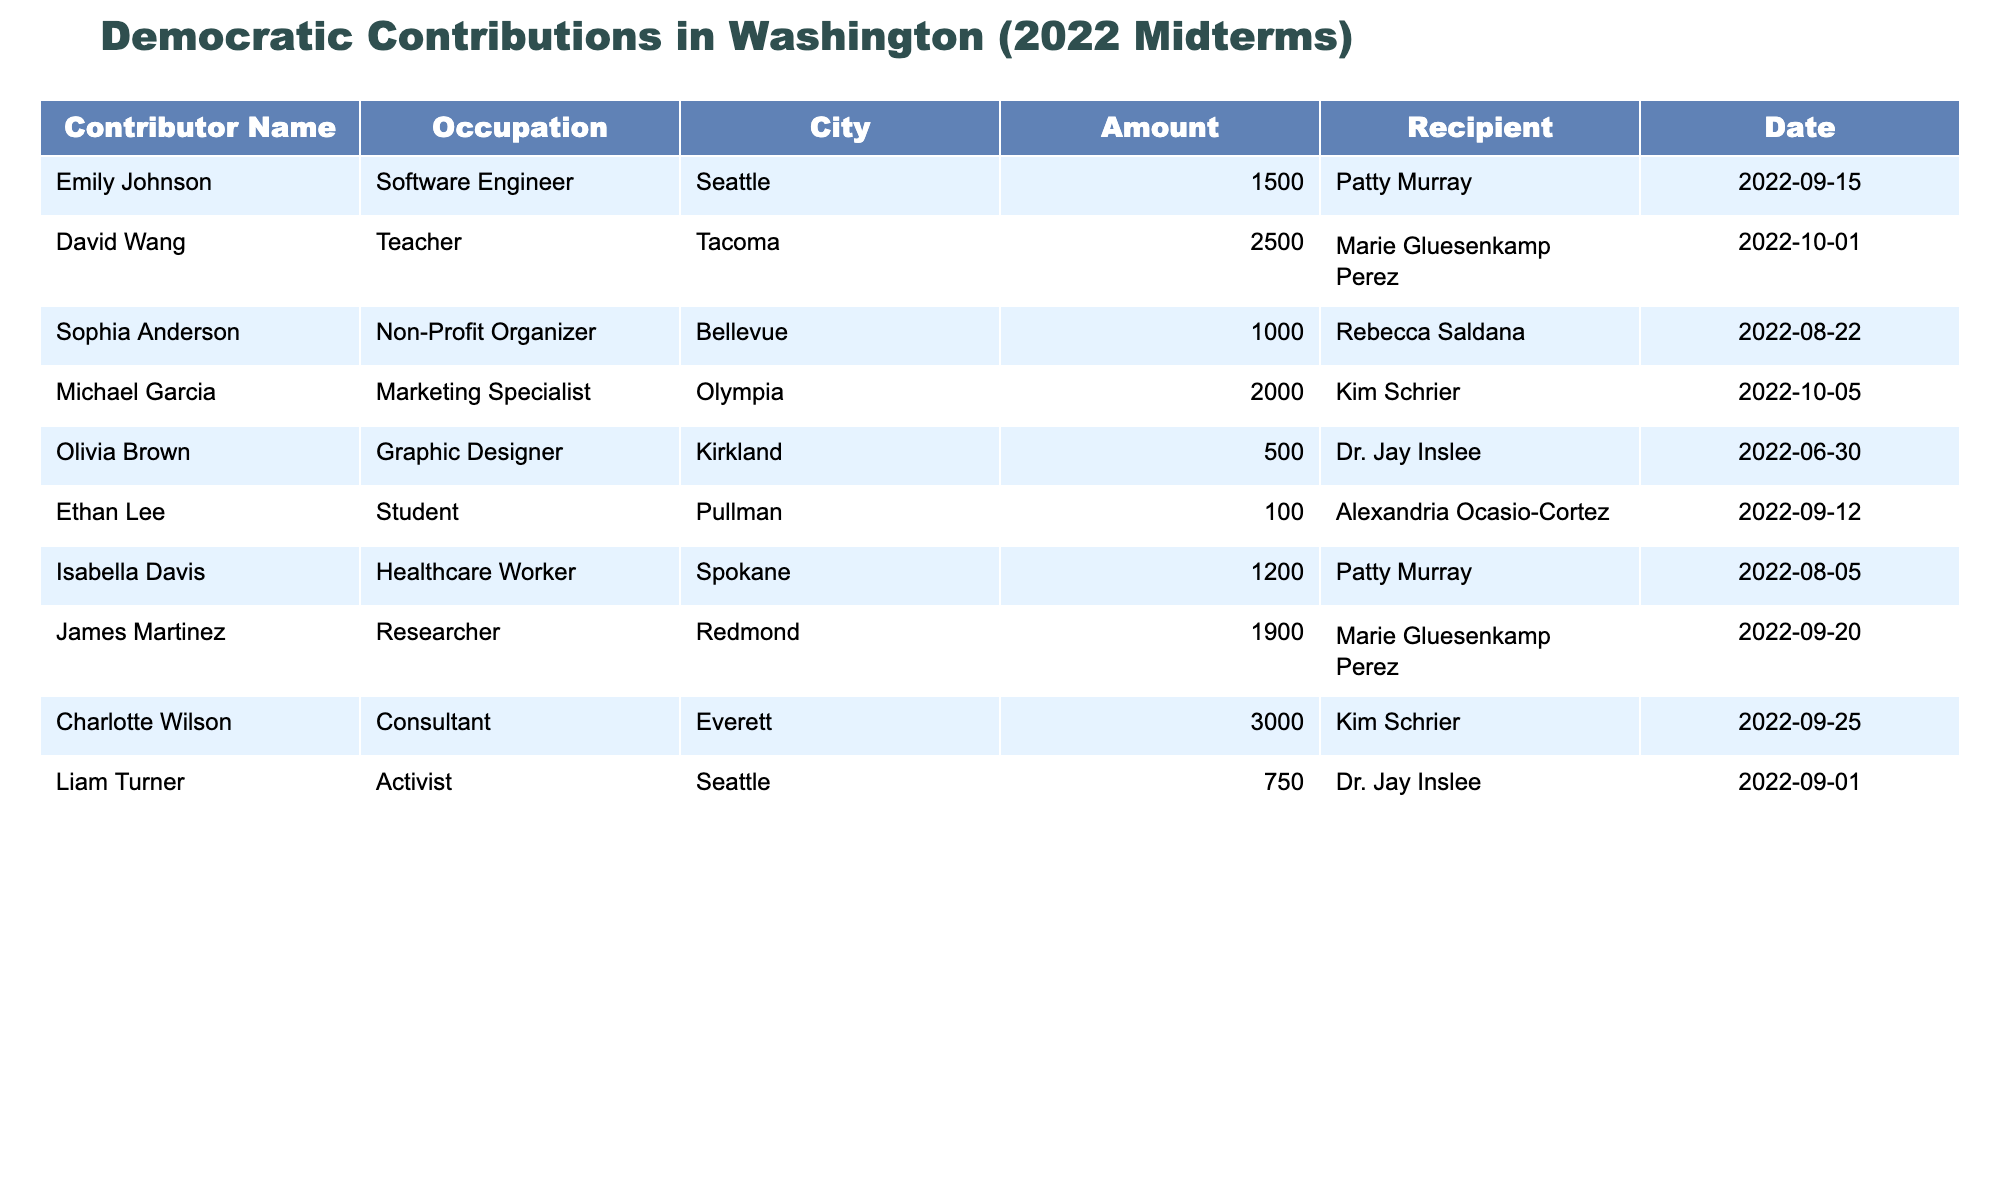What is the largest contribution made by a single individual in the table? The largest contribution in the table is $3000, made by Charlotte Wilson. This can be easily identified by looking through the "Amount" column to find the highest value.
Answer: $3000 Which recipient received the most total money from Washington residents based on the table? To find this, we review the "Recipient" column and sum the amounts associated with each one. Kim Schrier received $500 + $2000 + $3000 = $4500, making her the one with the most contributions.
Answer: Kim Schrier How many contributions were made by people living in Seattle? The table lists contributions from Emily Johnson and Liam Turner from Seattle, totaling two contributions. Each contributor can be directly counted by checking the "City" column for the entries that show Seattle.
Answer: 2 Is there any contributor who is a student? In the "Occupation" column, Ethan Lee is listed as a student, confirming that yes, there is a contributor who is a student.
Answer: Yes What is the total amount contributed by all contributors from Tacoma? In the table, David Wang from Tacoma contributed $2500. Since he's the only contributor from Tacoma in the table, his contribution is the total amount.
Answer: $2500 Which contributor has the highest contribution in the table, and which candidate did they support? Reviewing the "Amount" column, Charlotte Wilson gave $3000 to Kim Schrier. By finding the maximum value, we can attribute the recipient correctly.
Answer: Charlotte Wilson supported Kim Schrier Calculate the average contribution amount from all contributors listed. The total contributions sum up to $1500 + $2500 + $1000 + $2000 + $500 + $100 + $1200 + $1900 + $3000 + $750 = $13800. Since there are 10 contributors, the average is $13800 / 10 = $1380.
Answer: $1380 Are there more contributions made by healthcare workers or software engineers? By checking the "Occupation" column, there is one healthcare worker (Isabella Davis) who contributed $1200 and one software engineer (Emily Johnson) who contributed $1500. Since $1500 > $1200, it shows that more money came from software engineers.
Answer: Software engineers Which city has the most contributors in the table? Analyzing the "City" column shows that Seattle and Tacoma have two contributors each, while other cities only have one. Since they are tied, we conclude that these are the cities with the most contributors.
Answer: Seattle and Tacoma What is the sum of contributions made to Dr. Jay Inslee? Contributions listed for Dr. Jay Inslee are $500 from Olivia Brown and $750 from Liam Turner, totaling $500 + $750 = $1250.
Answer: $1250 